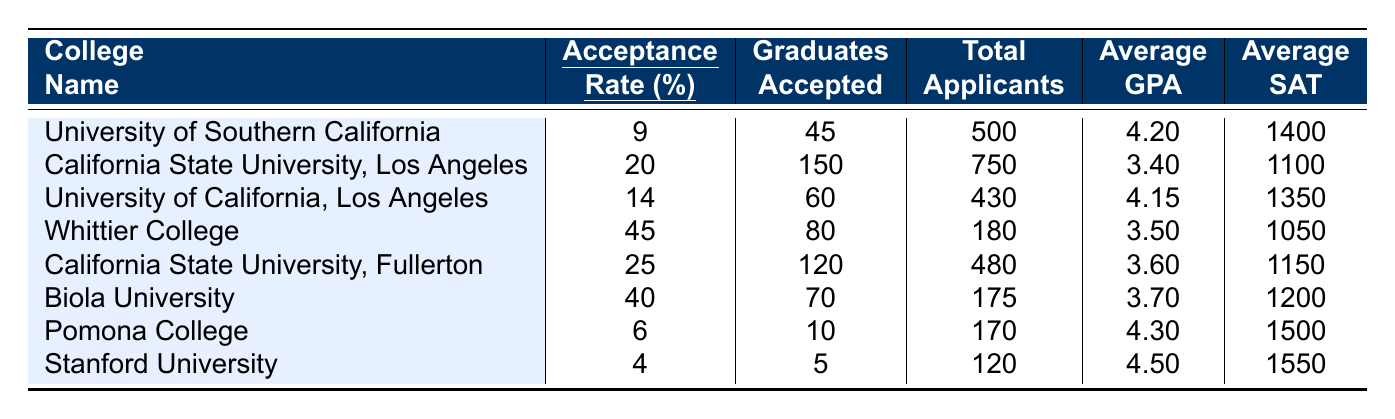What is the acceptance rate for Whittier College? The acceptance rate for Whittier College is listed in the table under the "Accept. Rate (%)" column next to its name. It shows 45%.
Answer: 45% Which college has the highest acceptance rate among those listed? By comparing the acceptance rates in the table, Whittier College at 45% has the highest acceptance rate of all the colleges listed.
Answer: Whittier College How many graduates from California State University, Fullerton were accepted? The number of graduates accepted for California State University, Fullerton can be found in the "Graduates Accepted" column next to its name, which states 120.
Answer: 120 What is the average GPA of graduates accepted by Stanford University? The average GPA for Stanford University can be found in the "Average GPA" column next to its name, which shows 4.50.
Answer: 4.50 What is the total number of applicants to Biola University? The total number of applicants for Biola University is shown in the "Total Applicants" column next to its name, listing 175 applicants.
Answer: 175 Which university has the lowest average SAT score among those listed? Upon examining the "Average SAT" column, Whittier College has the lowest average SAT score at 1050.
Answer: Whittier College What is the average acceptance rate of all the colleges listed? First, calculate the sum of all acceptance rates: (9 + 20 + 14 + 45 + 25 + 40 + 6 + 4) = 163. Then, divide by the number of colleges (8): 163 / 8 = 20.375.
Answer: 20.38 How many total applicants were there to the University of California, Los Angeles? The total applicants to the University of California, Los Angeles is noted in the "Total Applicants" column, which indicates 430 applicants.
Answer: 430 Are there more graduates accepted by California State University, Los Angeles than by Pomona College? Comparing the "Graduates Accepted" for both colleges: CSU Los Angeles has 150 graduates accepted, while Pomona College has 10. Since 150 is greater than 10, the statement is true.
Answer: Yes What is the difference in acceptance rates between Stanford University and Biola University? The acceptance rate for Stanford University is 4%, and for Biola University, it is 40%. The difference is 40% - 4% = 36%.
Answer: 36% 